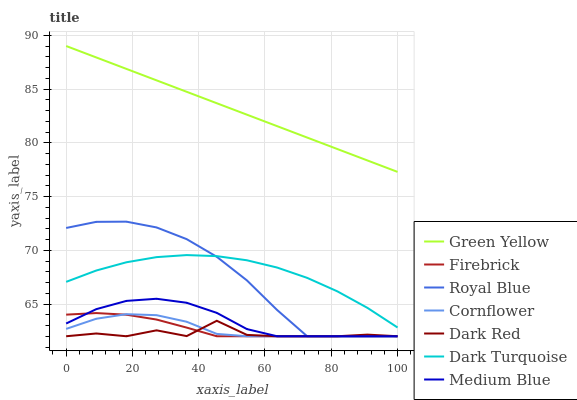Does Dark Red have the minimum area under the curve?
Answer yes or no. Yes. Does Green Yellow have the maximum area under the curve?
Answer yes or no. Yes. Does Firebrick have the minimum area under the curve?
Answer yes or no. No. Does Firebrick have the maximum area under the curve?
Answer yes or no. No. Is Green Yellow the smoothest?
Answer yes or no. Yes. Is Dark Red the roughest?
Answer yes or no. Yes. Is Firebrick the smoothest?
Answer yes or no. No. Is Firebrick the roughest?
Answer yes or no. No. Does Cornflower have the lowest value?
Answer yes or no. Yes. Does Dark Turquoise have the lowest value?
Answer yes or no. No. Does Green Yellow have the highest value?
Answer yes or no. Yes. Does Firebrick have the highest value?
Answer yes or no. No. Is Dark Red less than Green Yellow?
Answer yes or no. Yes. Is Green Yellow greater than Medium Blue?
Answer yes or no. Yes. Does Firebrick intersect Dark Red?
Answer yes or no. Yes. Is Firebrick less than Dark Red?
Answer yes or no. No. Is Firebrick greater than Dark Red?
Answer yes or no. No. Does Dark Red intersect Green Yellow?
Answer yes or no. No. 